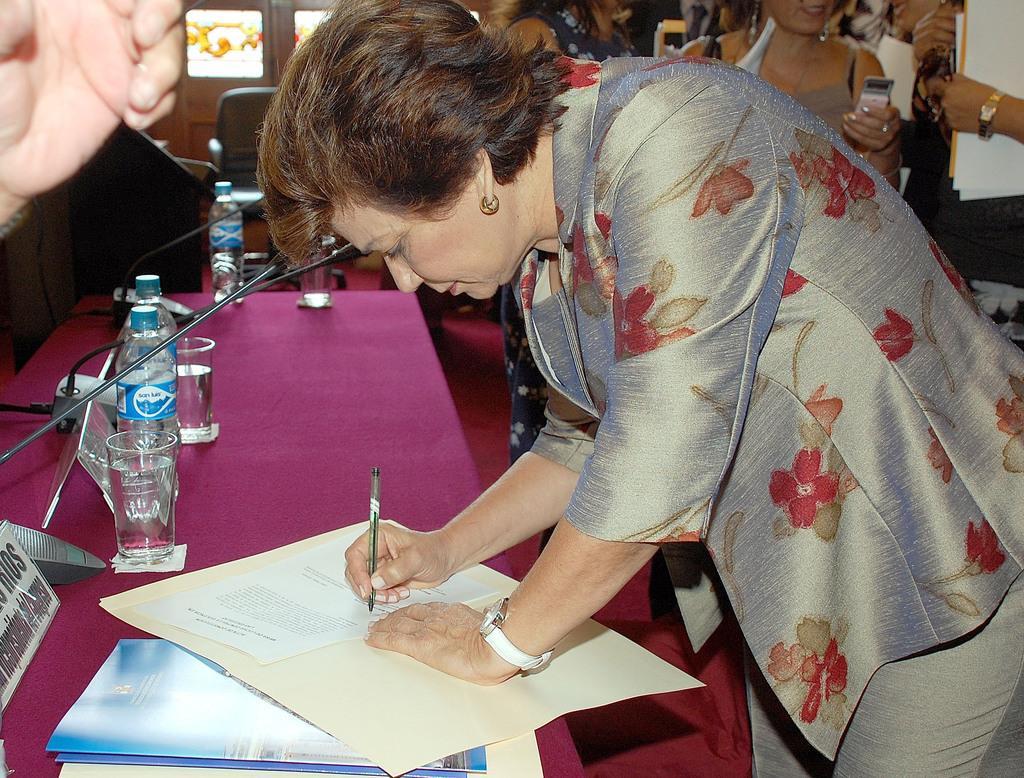How would you summarize this image in a sentence or two? In this picture we can see a woman who is writing on the paper. This is table. On the table there are bottles, and glasses. 